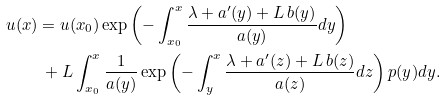Convert formula to latex. <formula><loc_0><loc_0><loc_500><loc_500>u ( x ) & = u ( x _ { 0 } ) \exp \left ( - \int _ { x _ { 0 } } ^ { x } \frac { \lambda + a ^ { \prime } ( y ) + L \, b ( y ) } { a ( y ) } d y \right ) \\ & \ + L \int _ { x _ { 0 } } ^ { x } \frac { 1 } { a ( y ) } \exp \left ( - \int _ { y } ^ { x } \frac { \lambda + a ^ { \prime } ( z ) + L \, b ( z ) } { a ( z ) } d z \right ) p ( y ) d y .</formula> 